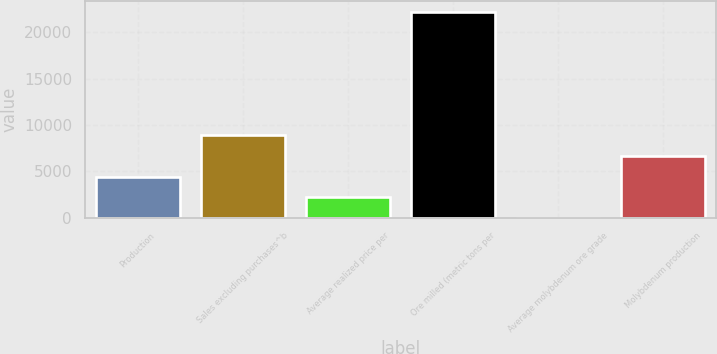Convert chart to OTSL. <chart><loc_0><loc_0><loc_500><loc_500><bar_chart><fcel>Production<fcel>Sales excluding purchases^b<fcel>Average realized price per<fcel>Ore milled (metric tons per<fcel>Average molybdenum ore grade<fcel>Molybdenum production<nl><fcel>4440.19<fcel>8880.15<fcel>2220.21<fcel>22200<fcel>0.23<fcel>6660.17<nl></chart> 